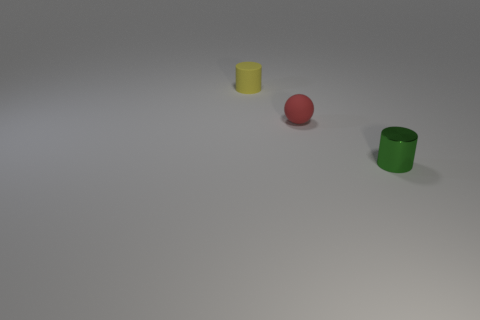Does the small cylinder behind the tiny metallic object have the same color as the small metallic thing?
Offer a very short reply. No. How many other things are the same color as the metal cylinder?
Your answer should be very brief. 0. What number of small things are either brown metal cubes or green cylinders?
Provide a succinct answer. 1. Is the number of big brown matte balls greater than the number of red matte objects?
Ensure brevity in your answer.  No. Do the red thing and the yellow object have the same material?
Your answer should be compact. Yes. Is there any other thing that has the same material as the ball?
Your answer should be very brief. Yes. Are there more small red things right of the metal cylinder than small green things?
Ensure brevity in your answer.  No. Is the color of the matte cylinder the same as the tiny metallic object?
Your answer should be very brief. No. What number of small green objects have the same shape as the small red object?
Your answer should be compact. 0. There is a red sphere that is the same material as the yellow object; what is its size?
Provide a succinct answer. Small. 